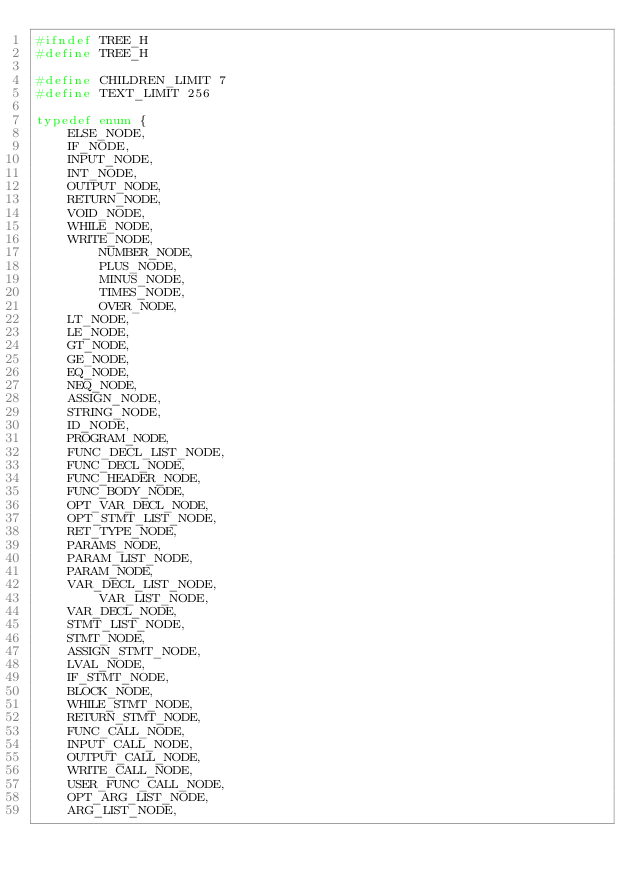<code> <loc_0><loc_0><loc_500><loc_500><_C_>#ifndef TREE_H
#define TREE_H

#define CHILDREN_LIMIT 7
#define TEXT_LIMIT 256

typedef enum {
	ELSE_NODE,
	IF_NODE,
	INPUT_NODE,
	INT_NODE,
	OUTPUT_NODE,
	RETURN_NODE,
	VOID_NODE,
	WHILE_NODE,
	WRITE_NODE,
    	NUMBER_NODE,
    	PLUS_NODE,
    	MINUS_NODE,
    	TIMES_NODE,
    	OVER_NODE,
	LT_NODE,
	LE_NODE,
	GT_NODE,
	GE_NODE,
	EQ_NODE,
	NEQ_NODE,
	ASSIGN_NODE,
	STRING_NODE,
	ID_NODE,
	PROGRAM_NODE,
	FUNC_DECL_LIST_NODE,
	FUNC_DECL_NODE,
	FUNC_HEADER_NODE,
	FUNC_BODY_NODE,
	OPT_VAR_DECL_NODE,
	OPT_STMT_LIST_NODE,
	RET_TYPE_NODE,
	PARAMS_NODE,
	PARAM_LIST_NODE,
	PARAM_NODE,
	VAR_DECL_LIST_NODE,
        VAR_LIST_NODE,
	VAR_DECL_NODE,
	STMT_LIST_NODE,
	STMT_NODE,
	ASSIGN_STMT_NODE,
	LVAL_NODE,
	IF_STMT_NODE,
	BLOCK_NODE,
	WHILE_STMT_NODE,
	RETURN_STMT_NODE,
	FUNC_CALL_NODE,
	INPUT_CALL_NODE,
	OUTPUT_CALL_NODE,
	WRITE_CALL_NODE,
	USER_FUNC_CALL_NODE,
	OPT_ARG_LIST_NODE,
	ARG_LIST_NODE,</code> 